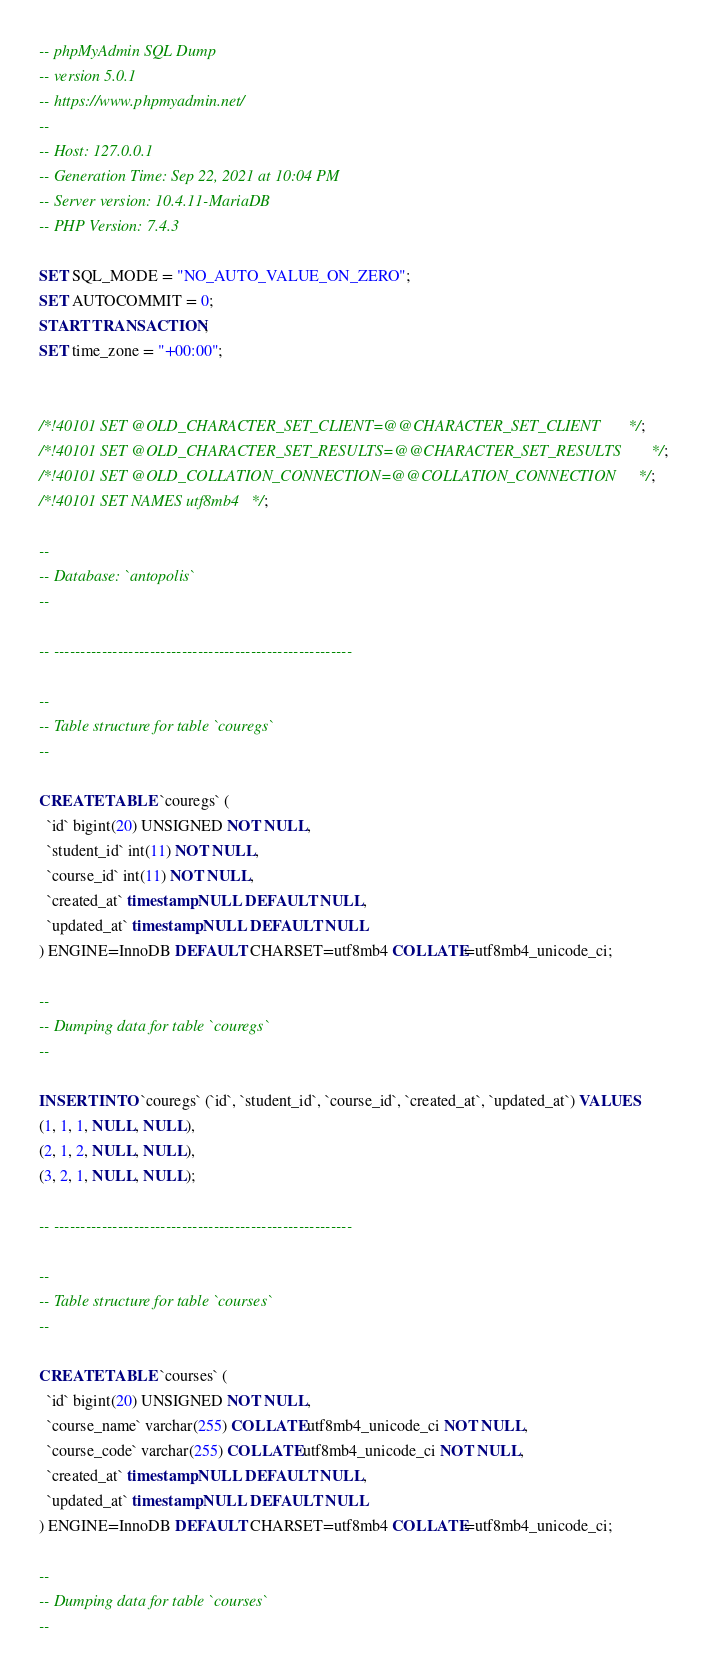<code> <loc_0><loc_0><loc_500><loc_500><_SQL_>-- phpMyAdmin SQL Dump
-- version 5.0.1
-- https://www.phpmyadmin.net/
--
-- Host: 127.0.0.1
-- Generation Time: Sep 22, 2021 at 10:04 PM
-- Server version: 10.4.11-MariaDB
-- PHP Version: 7.4.3

SET SQL_MODE = "NO_AUTO_VALUE_ON_ZERO";
SET AUTOCOMMIT = 0;
START TRANSACTION;
SET time_zone = "+00:00";


/*!40101 SET @OLD_CHARACTER_SET_CLIENT=@@CHARACTER_SET_CLIENT */;
/*!40101 SET @OLD_CHARACTER_SET_RESULTS=@@CHARACTER_SET_RESULTS */;
/*!40101 SET @OLD_COLLATION_CONNECTION=@@COLLATION_CONNECTION */;
/*!40101 SET NAMES utf8mb4 */;

--
-- Database: `antopolis`
--

-- --------------------------------------------------------

--
-- Table structure for table `couregs`
--

CREATE TABLE `couregs` (
  `id` bigint(20) UNSIGNED NOT NULL,
  `student_id` int(11) NOT NULL,
  `course_id` int(11) NOT NULL,
  `created_at` timestamp NULL DEFAULT NULL,
  `updated_at` timestamp NULL DEFAULT NULL
) ENGINE=InnoDB DEFAULT CHARSET=utf8mb4 COLLATE=utf8mb4_unicode_ci;

--
-- Dumping data for table `couregs`
--

INSERT INTO `couregs` (`id`, `student_id`, `course_id`, `created_at`, `updated_at`) VALUES
(1, 1, 1, NULL, NULL),
(2, 1, 2, NULL, NULL),
(3, 2, 1, NULL, NULL);

-- --------------------------------------------------------

--
-- Table structure for table `courses`
--

CREATE TABLE `courses` (
  `id` bigint(20) UNSIGNED NOT NULL,
  `course_name` varchar(255) COLLATE utf8mb4_unicode_ci NOT NULL,
  `course_code` varchar(255) COLLATE utf8mb4_unicode_ci NOT NULL,
  `created_at` timestamp NULL DEFAULT NULL,
  `updated_at` timestamp NULL DEFAULT NULL
) ENGINE=InnoDB DEFAULT CHARSET=utf8mb4 COLLATE=utf8mb4_unicode_ci;

--
-- Dumping data for table `courses`
--
</code> 